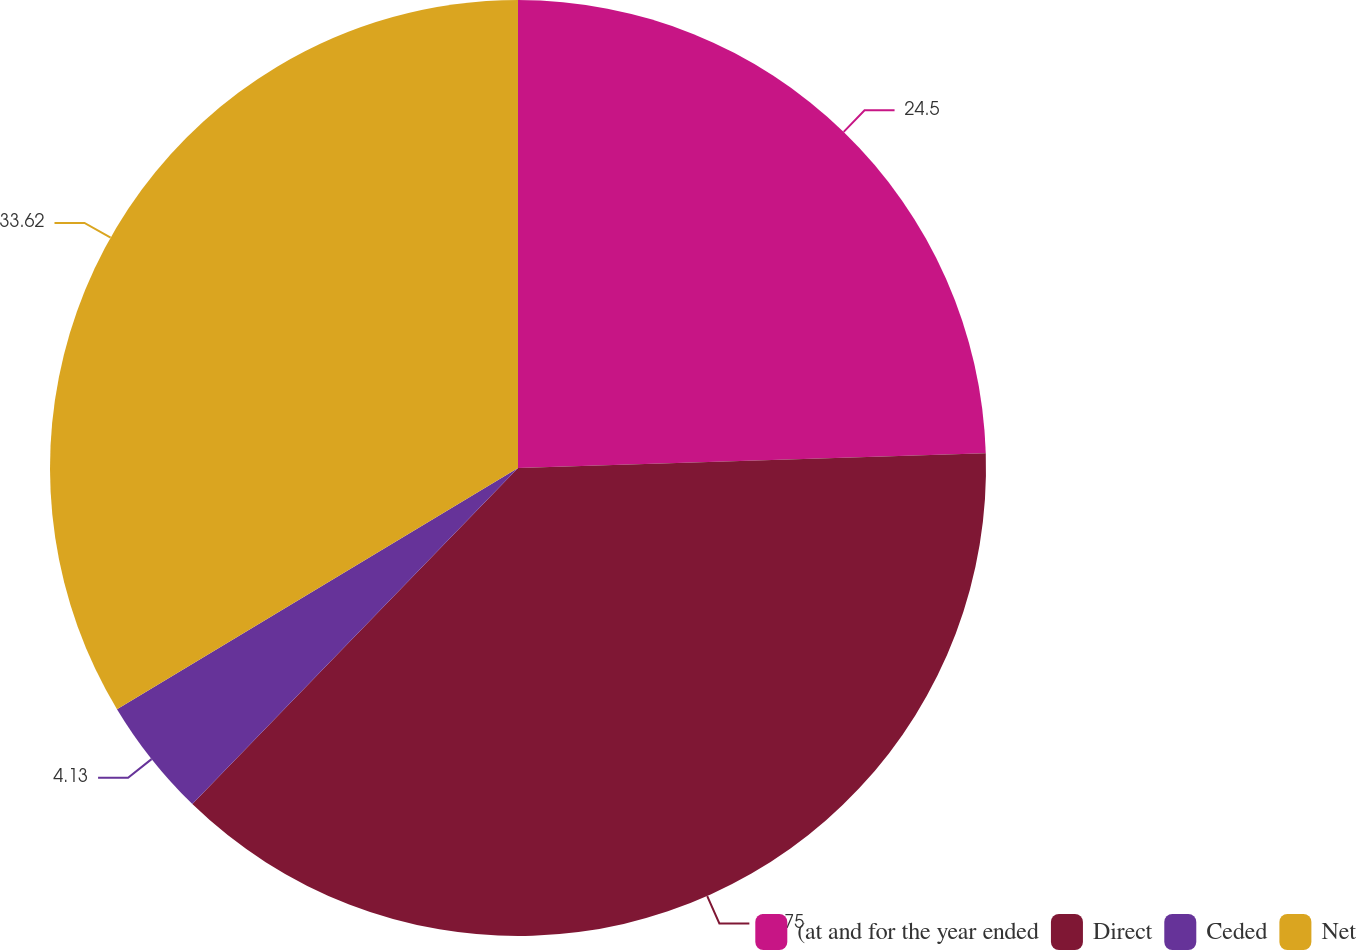<chart> <loc_0><loc_0><loc_500><loc_500><pie_chart><fcel>(at and for the year ended<fcel>Direct<fcel>Ceded<fcel>Net<nl><fcel>24.5%<fcel>37.75%<fcel>4.13%<fcel>33.62%<nl></chart> 